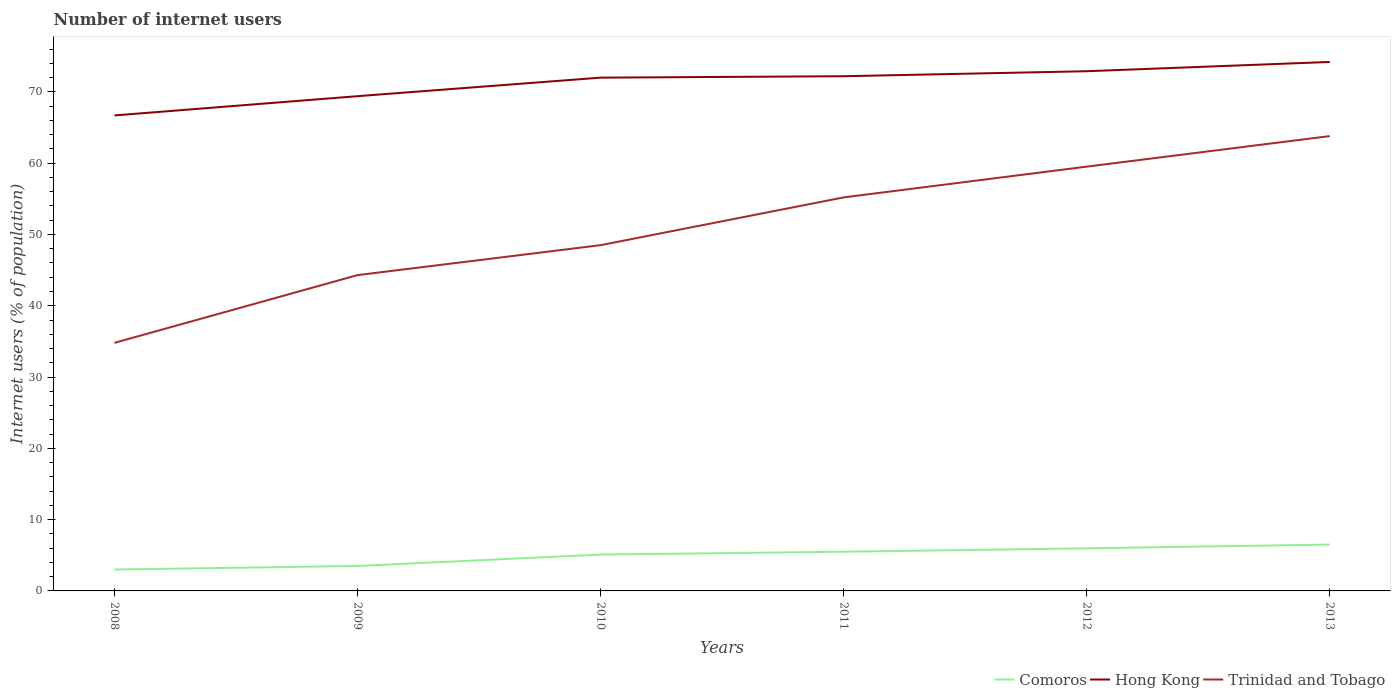How many different coloured lines are there?
Keep it short and to the point. 3. Does the line corresponding to Trinidad and Tobago intersect with the line corresponding to Hong Kong?
Ensure brevity in your answer.  No. Is the number of lines equal to the number of legend labels?
Ensure brevity in your answer.  Yes. Across all years, what is the maximum number of internet users in Trinidad and Tobago?
Your response must be concise. 34.8. What is the total number of internet users in Comoros in the graph?
Provide a short and direct response. -1.4. What is the difference between the highest and the second highest number of internet users in Trinidad and Tobago?
Give a very brief answer. 29. Is the number of internet users in Comoros strictly greater than the number of internet users in Hong Kong over the years?
Give a very brief answer. Yes. How many lines are there?
Offer a very short reply. 3. How many years are there in the graph?
Provide a short and direct response. 6. Does the graph contain any zero values?
Your response must be concise. No. Does the graph contain grids?
Provide a short and direct response. No. Where does the legend appear in the graph?
Ensure brevity in your answer.  Bottom right. How are the legend labels stacked?
Offer a terse response. Horizontal. What is the title of the graph?
Give a very brief answer. Number of internet users. What is the label or title of the Y-axis?
Give a very brief answer. Internet users (% of population). What is the Internet users (% of population) of Comoros in 2008?
Provide a succinct answer. 3. What is the Internet users (% of population) in Hong Kong in 2008?
Your response must be concise. 66.7. What is the Internet users (% of population) in Trinidad and Tobago in 2008?
Provide a succinct answer. 34.8. What is the Internet users (% of population) of Comoros in 2009?
Ensure brevity in your answer.  3.5. What is the Internet users (% of population) of Hong Kong in 2009?
Give a very brief answer. 69.4. What is the Internet users (% of population) of Trinidad and Tobago in 2009?
Provide a short and direct response. 44.3. What is the Internet users (% of population) of Hong Kong in 2010?
Give a very brief answer. 72. What is the Internet users (% of population) in Trinidad and Tobago in 2010?
Your answer should be very brief. 48.5. What is the Internet users (% of population) in Hong Kong in 2011?
Keep it short and to the point. 72.2. What is the Internet users (% of population) in Trinidad and Tobago in 2011?
Offer a terse response. 55.2. What is the Internet users (% of population) in Comoros in 2012?
Provide a short and direct response. 5.98. What is the Internet users (% of population) of Hong Kong in 2012?
Provide a succinct answer. 72.9. What is the Internet users (% of population) of Trinidad and Tobago in 2012?
Offer a terse response. 59.52. What is the Internet users (% of population) in Comoros in 2013?
Offer a terse response. 6.5. What is the Internet users (% of population) in Hong Kong in 2013?
Keep it short and to the point. 74.2. What is the Internet users (% of population) of Trinidad and Tobago in 2013?
Keep it short and to the point. 63.8. Across all years, what is the maximum Internet users (% of population) of Hong Kong?
Offer a very short reply. 74.2. Across all years, what is the maximum Internet users (% of population) of Trinidad and Tobago?
Keep it short and to the point. 63.8. Across all years, what is the minimum Internet users (% of population) of Comoros?
Ensure brevity in your answer.  3. Across all years, what is the minimum Internet users (% of population) in Hong Kong?
Give a very brief answer. 66.7. Across all years, what is the minimum Internet users (% of population) of Trinidad and Tobago?
Provide a succinct answer. 34.8. What is the total Internet users (% of population) in Comoros in the graph?
Your answer should be compact. 29.58. What is the total Internet users (% of population) of Hong Kong in the graph?
Your answer should be compact. 427.4. What is the total Internet users (% of population) of Trinidad and Tobago in the graph?
Provide a short and direct response. 306.12. What is the difference between the Internet users (% of population) in Trinidad and Tobago in 2008 and that in 2009?
Provide a succinct answer. -9.5. What is the difference between the Internet users (% of population) of Comoros in 2008 and that in 2010?
Ensure brevity in your answer.  -2.1. What is the difference between the Internet users (% of population) of Hong Kong in 2008 and that in 2010?
Provide a succinct answer. -5.3. What is the difference between the Internet users (% of population) of Trinidad and Tobago in 2008 and that in 2010?
Offer a terse response. -13.7. What is the difference between the Internet users (% of population) of Trinidad and Tobago in 2008 and that in 2011?
Offer a very short reply. -20.4. What is the difference between the Internet users (% of population) of Comoros in 2008 and that in 2012?
Provide a succinct answer. -2.98. What is the difference between the Internet users (% of population) of Hong Kong in 2008 and that in 2012?
Your response must be concise. -6.2. What is the difference between the Internet users (% of population) in Trinidad and Tobago in 2008 and that in 2012?
Provide a succinct answer. -24.72. What is the difference between the Internet users (% of population) in Comoros in 2008 and that in 2013?
Your response must be concise. -3.5. What is the difference between the Internet users (% of population) of Trinidad and Tobago in 2008 and that in 2013?
Provide a succinct answer. -29. What is the difference between the Internet users (% of population) in Trinidad and Tobago in 2009 and that in 2011?
Provide a succinct answer. -10.9. What is the difference between the Internet users (% of population) in Comoros in 2009 and that in 2012?
Provide a succinct answer. -2.48. What is the difference between the Internet users (% of population) of Hong Kong in 2009 and that in 2012?
Provide a short and direct response. -3.5. What is the difference between the Internet users (% of population) in Trinidad and Tobago in 2009 and that in 2012?
Offer a very short reply. -15.22. What is the difference between the Internet users (% of population) in Comoros in 2009 and that in 2013?
Provide a short and direct response. -3. What is the difference between the Internet users (% of population) in Trinidad and Tobago in 2009 and that in 2013?
Make the answer very short. -19.5. What is the difference between the Internet users (% of population) of Trinidad and Tobago in 2010 and that in 2011?
Your answer should be compact. -6.7. What is the difference between the Internet users (% of population) of Comoros in 2010 and that in 2012?
Provide a succinct answer. -0.88. What is the difference between the Internet users (% of population) of Trinidad and Tobago in 2010 and that in 2012?
Offer a very short reply. -11.02. What is the difference between the Internet users (% of population) of Trinidad and Tobago in 2010 and that in 2013?
Your answer should be very brief. -15.3. What is the difference between the Internet users (% of population) in Comoros in 2011 and that in 2012?
Make the answer very short. -0.48. What is the difference between the Internet users (% of population) of Trinidad and Tobago in 2011 and that in 2012?
Your response must be concise. -4.32. What is the difference between the Internet users (% of population) in Hong Kong in 2011 and that in 2013?
Ensure brevity in your answer.  -2. What is the difference between the Internet users (% of population) of Comoros in 2012 and that in 2013?
Offer a very short reply. -0.52. What is the difference between the Internet users (% of population) in Hong Kong in 2012 and that in 2013?
Keep it short and to the point. -1.3. What is the difference between the Internet users (% of population) in Trinidad and Tobago in 2012 and that in 2013?
Ensure brevity in your answer.  -4.28. What is the difference between the Internet users (% of population) in Comoros in 2008 and the Internet users (% of population) in Hong Kong in 2009?
Ensure brevity in your answer.  -66.4. What is the difference between the Internet users (% of population) of Comoros in 2008 and the Internet users (% of population) of Trinidad and Tobago in 2009?
Your answer should be compact. -41.3. What is the difference between the Internet users (% of population) in Hong Kong in 2008 and the Internet users (% of population) in Trinidad and Tobago in 2009?
Offer a terse response. 22.4. What is the difference between the Internet users (% of population) of Comoros in 2008 and the Internet users (% of population) of Hong Kong in 2010?
Provide a succinct answer. -69. What is the difference between the Internet users (% of population) in Comoros in 2008 and the Internet users (% of population) in Trinidad and Tobago in 2010?
Offer a very short reply. -45.5. What is the difference between the Internet users (% of population) in Comoros in 2008 and the Internet users (% of population) in Hong Kong in 2011?
Make the answer very short. -69.2. What is the difference between the Internet users (% of population) of Comoros in 2008 and the Internet users (% of population) of Trinidad and Tobago in 2011?
Your response must be concise. -52.2. What is the difference between the Internet users (% of population) of Comoros in 2008 and the Internet users (% of population) of Hong Kong in 2012?
Your answer should be very brief. -69.9. What is the difference between the Internet users (% of population) of Comoros in 2008 and the Internet users (% of population) of Trinidad and Tobago in 2012?
Offer a terse response. -56.52. What is the difference between the Internet users (% of population) of Hong Kong in 2008 and the Internet users (% of population) of Trinidad and Tobago in 2012?
Keep it short and to the point. 7.18. What is the difference between the Internet users (% of population) in Comoros in 2008 and the Internet users (% of population) in Hong Kong in 2013?
Your response must be concise. -71.2. What is the difference between the Internet users (% of population) in Comoros in 2008 and the Internet users (% of population) in Trinidad and Tobago in 2013?
Provide a short and direct response. -60.8. What is the difference between the Internet users (% of population) in Comoros in 2009 and the Internet users (% of population) in Hong Kong in 2010?
Offer a terse response. -68.5. What is the difference between the Internet users (% of population) of Comoros in 2009 and the Internet users (% of population) of Trinidad and Tobago in 2010?
Offer a very short reply. -45. What is the difference between the Internet users (% of population) in Hong Kong in 2009 and the Internet users (% of population) in Trinidad and Tobago in 2010?
Your answer should be very brief. 20.9. What is the difference between the Internet users (% of population) of Comoros in 2009 and the Internet users (% of population) of Hong Kong in 2011?
Offer a very short reply. -68.7. What is the difference between the Internet users (% of population) in Comoros in 2009 and the Internet users (% of population) in Trinidad and Tobago in 2011?
Keep it short and to the point. -51.7. What is the difference between the Internet users (% of population) in Comoros in 2009 and the Internet users (% of population) in Hong Kong in 2012?
Offer a terse response. -69.4. What is the difference between the Internet users (% of population) in Comoros in 2009 and the Internet users (% of population) in Trinidad and Tobago in 2012?
Ensure brevity in your answer.  -56.02. What is the difference between the Internet users (% of population) in Hong Kong in 2009 and the Internet users (% of population) in Trinidad and Tobago in 2012?
Your response must be concise. 9.88. What is the difference between the Internet users (% of population) of Comoros in 2009 and the Internet users (% of population) of Hong Kong in 2013?
Provide a succinct answer. -70.7. What is the difference between the Internet users (% of population) in Comoros in 2009 and the Internet users (% of population) in Trinidad and Tobago in 2013?
Provide a short and direct response. -60.3. What is the difference between the Internet users (% of population) of Hong Kong in 2009 and the Internet users (% of population) of Trinidad and Tobago in 2013?
Provide a succinct answer. 5.6. What is the difference between the Internet users (% of population) in Comoros in 2010 and the Internet users (% of population) in Hong Kong in 2011?
Your answer should be very brief. -67.1. What is the difference between the Internet users (% of population) of Comoros in 2010 and the Internet users (% of population) of Trinidad and Tobago in 2011?
Make the answer very short. -50.1. What is the difference between the Internet users (% of population) in Comoros in 2010 and the Internet users (% of population) in Hong Kong in 2012?
Offer a terse response. -67.8. What is the difference between the Internet users (% of population) of Comoros in 2010 and the Internet users (% of population) of Trinidad and Tobago in 2012?
Provide a succinct answer. -54.42. What is the difference between the Internet users (% of population) of Hong Kong in 2010 and the Internet users (% of population) of Trinidad and Tobago in 2012?
Your answer should be very brief. 12.48. What is the difference between the Internet users (% of population) of Comoros in 2010 and the Internet users (% of population) of Hong Kong in 2013?
Provide a short and direct response. -69.1. What is the difference between the Internet users (% of population) in Comoros in 2010 and the Internet users (% of population) in Trinidad and Tobago in 2013?
Your answer should be compact. -58.7. What is the difference between the Internet users (% of population) of Hong Kong in 2010 and the Internet users (% of population) of Trinidad and Tobago in 2013?
Provide a succinct answer. 8.2. What is the difference between the Internet users (% of population) of Comoros in 2011 and the Internet users (% of population) of Hong Kong in 2012?
Give a very brief answer. -67.4. What is the difference between the Internet users (% of population) of Comoros in 2011 and the Internet users (% of population) of Trinidad and Tobago in 2012?
Offer a very short reply. -54.02. What is the difference between the Internet users (% of population) of Hong Kong in 2011 and the Internet users (% of population) of Trinidad and Tobago in 2012?
Your response must be concise. 12.68. What is the difference between the Internet users (% of population) of Comoros in 2011 and the Internet users (% of population) of Hong Kong in 2013?
Offer a terse response. -68.7. What is the difference between the Internet users (% of population) of Comoros in 2011 and the Internet users (% of population) of Trinidad and Tobago in 2013?
Provide a short and direct response. -58.3. What is the difference between the Internet users (% of population) in Hong Kong in 2011 and the Internet users (% of population) in Trinidad and Tobago in 2013?
Keep it short and to the point. 8.4. What is the difference between the Internet users (% of population) of Comoros in 2012 and the Internet users (% of population) of Hong Kong in 2013?
Your response must be concise. -68.22. What is the difference between the Internet users (% of population) in Comoros in 2012 and the Internet users (% of population) in Trinidad and Tobago in 2013?
Keep it short and to the point. -57.82. What is the average Internet users (% of population) in Comoros per year?
Offer a very short reply. 4.93. What is the average Internet users (% of population) in Hong Kong per year?
Provide a short and direct response. 71.23. What is the average Internet users (% of population) in Trinidad and Tobago per year?
Offer a terse response. 51.02. In the year 2008, what is the difference between the Internet users (% of population) in Comoros and Internet users (% of population) in Hong Kong?
Make the answer very short. -63.7. In the year 2008, what is the difference between the Internet users (% of population) of Comoros and Internet users (% of population) of Trinidad and Tobago?
Your answer should be very brief. -31.8. In the year 2008, what is the difference between the Internet users (% of population) in Hong Kong and Internet users (% of population) in Trinidad and Tobago?
Offer a terse response. 31.9. In the year 2009, what is the difference between the Internet users (% of population) in Comoros and Internet users (% of population) in Hong Kong?
Provide a short and direct response. -65.9. In the year 2009, what is the difference between the Internet users (% of population) in Comoros and Internet users (% of population) in Trinidad and Tobago?
Provide a short and direct response. -40.8. In the year 2009, what is the difference between the Internet users (% of population) in Hong Kong and Internet users (% of population) in Trinidad and Tobago?
Your response must be concise. 25.1. In the year 2010, what is the difference between the Internet users (% of population) of Comoros and Internet users (% of population) of Hong Kong?
Make the answer very short. -66.9. In the year 2010, what is the difference between the Internet users (% of population) of Comoros and Internet users (% of population) of Trinidad and Tobago?
Provide a succinct answer. -43.4. In the year 2010, what is the difference between the Internet users (% of population) of Hong Kong and Internet users (% of population) of Trinidad and Tobago?
Provide a short and direct response. 23.5. In the year 2011, what is the difference between the Internet users (% of population) in Comoros and Internet users (% of population) in Hong Kong?
Provide a succinct answer. -66.7. In the year 2011, what is the difference between the Internet users (% of population) of Comoros and Internet users (% of population) of Trinidad and Tobago?
Your response must be concise. -49.7. In the year 2011, what is the difference between the Internet users (% of population) of Hong Kong and Internet users (% of population) of Trinidad and Tobago?
Provide a succinct answer. 17. In the year 2012, what is the difference between the Internet users (% of population) in Comoros and Internet users (% of population) in Hong Kong?
Your answer should be compact. -66.92. In the year 2012, what is the difference between the Internet users (% of population) in Comoros and Internet users (% of population) in Trinidad and Tobago?
Provide a short and direct response. -53.54. In the year 2012, what is the difference between the Internet users (% of population) of Hong Kong and Internet users (% of population) of Trinidad and Tobago?
Offer a very short reply. 13.38. In the year 2013, what is the difference between the Internet users (% of population) of Comoros and Internet users (% of population) of Hong Kong?
Give a very brief answer. -67.7. In the year 2013, what is the difference between the Internet users (% of population) of Comoros and Internet users (% of population) of Trinidad and Tobago?
Your answer should be very brief. -57.3. What is the ratio of the Internet users (% of population) of Hong Kong in 2008 to that in 2009?
Give a very brief answer. 0.96. What is the ratio of the Internet users (% of population) of Trinidad and Tobago in 2008 to that in 2009?
Make the answer very short. 0.79. What is the ratio of the Internet users (% of population) of Comoros in 2008 to that in 2010?
Give a very brief answer. 0.59. What is the ratio of the Internet users (% of population) in Hong Kong in 2008 to that in 2010?
Give a very brief answer. 0.93. What is the ratio of the Internet users (% of population) of Trinidad and Tobago in 2008 to that in 2010?
Offer a very short reply. 0.72. What is the ratio of the Internet users (% of population) in Comoros in 2008 to that in 2011?
Offer a terse response. 0.55. What is the ratio of the Internet users (% of population) in Hong Kong in 2008 to that in 2011?
Your answer should be compact. 0.92. What is the ratio of the Internet users (% of population) in Trinidad and Tobago in 2008 to that in 2011?
Provide a short and direct response. 0.63. What is the ratio of the Internet users (% of population) in Comoros in 2008 to that in 2012?
Your answer should be compact. 0.5. What is the ratio of the Internet users (% of population) of Hong Kong in 2008 to that in 2012?
Your response must be concise. 0.92. What is the ratio of the Internet users (% of population) of Trinidad and Tobago in 2008 to that in 2012?
Offer a terse response. 0.58. What is the ratio of the Internet users (% of population) in Comoros in 2008 to that in 2013?
Your answer should be very brief. 0.46. What is the ratio of the Internet users (% of population) in Hong Kong in 2008 to that in 2013?
Offer a terse response. 0.9. What is the ratio of the Internet users (% of population) in Trinidad and Tobago in 2008 to that in 2013?
Make the answer very short. 0.55. What is the ratio of the Internet users (% of population) of Comoros in 2009 to that in 2010?
Provide a short and direct response. 0.69. What is the ratio of the Internet users (% of population) in Hong Kong in 2009 to that in 2010?
Ensure brevity in your answer.  0.96. What is the ratio of the Internet users (% of population) in Trinidad and Tobago in 2009 to that in 2010?
Provide a short and direct response. 0.91. What is the ratio of the Internet users (% of population) in Comoros in 2009 to that in 2011?
Ensure brevity in your answer.  0.64. What is the ratio of the Internet users (% of population) of Hong Kong in 2009 to that in 2011?
Provide a succinct answer. 0.96. What is the ratio of the Internet users (% of population) in Trinidad and Tobago in 2009 to that in 2011?
Provide a succinct answer. 0.8. What is the ratio of the Internet users (% of population) of Comoros in 2009 to that in 2012?
Offer a terse response. 0.59. What is the ratio of the Internet users (% of population) of Trinidad and Tobago in 2009 to that in 2012?
Provide a succinct answer. 0.74. What is the ratio of the Internet users (% of population) in Comoros in 2009 to that in 2013?
Keep it short and to the point. 0.54. What is the ratio of the Internet users (% of population) of Hong Kong in 2009 to that in 2013?
Make the answer very short. 0.94. What is the ratio of the Internet users (% of population) in Trinidad and Tobago in 2009 to that in 2013?
Offer a terse response. 0.69. What is the ratio of the Internet users (% of population) in Comoros in 2010 to that in 2011?
Your response must be concise. 0.93. What is the ratio of the Internet users (% of population) of Trinidad and Tobago in 2010 to that in 2011?
Your answer should be very brief. 0.88. What is the ratio of the Internet users (% of population) of Comoros in 2010 to that in 2012?
Give a very brief answer. 0.85. What is the ratio of the Internet users (% of population) in Trinidad and Tobago in 2010 to that in 2012?
Offer a terse response. 0.81. What is the ratio of the Internet users (% of population) of Comoros in 2010 to that in 2013?
Your answer should be compact. 0.78. What is the ratio of the Internet users (% of population) of Hong Kong in 2010 to that in 2013?
Give a very brief answer. 0.97. What is the ratio of the Internet users (% of population) in Trinidad and Tobago in 2010 to that in 2013?
Your response must be concise. 0.76. What is the ratio of the Internet users (% of population) of Comoros in 2011 to that in 2012?
Provide a short and direct response. 0.92. What is the ratio of the Internet users (% of population) of Hong Kong in 2011 to that in 2012?
Your answer should be compact. 0.99. What is the ratio of the Internet users (% of population) of Trinidad and Tobago in 2011 to that in 2012?
Your answer should be compact. 0.93. What is the ratio of the Internet users (% of population) in Comoros in 2011 to that in 2013?
Your answer should be compact. 0.85. What is the ratio of the Internet users (% of population) of Trinidad and Tobago in 2011 to that in 2013?
Give a very brief answer. 0.87. What is the ratio of the Internet users (% of population) in Comoros in 2012 to that in 2013?
Your response must be concise. 0.92. What is the ratio of the Internet users (% of population) in Hong Kong in 2012 to that in 2013?
Provide a succinct answer. 0.98. What is the ratio of the Internet users (% of population) of Trinidad and Tobago in 2012 to that in 2013?
Offer a terse response. 0.93. What is the difference between the highest and the second highest Internet users (% of population) of Comoros?
Your response must be concise. 0.52. What is the difference between the highest and the second highest Internet users (% of population) in Trinidad and Tobago?
Offer a terse response. 4.28. What is the difference between the highest and the lowest Internet users (% of population) of Trinidad and Tobago?
Ensure brevity in your answer.  29. 